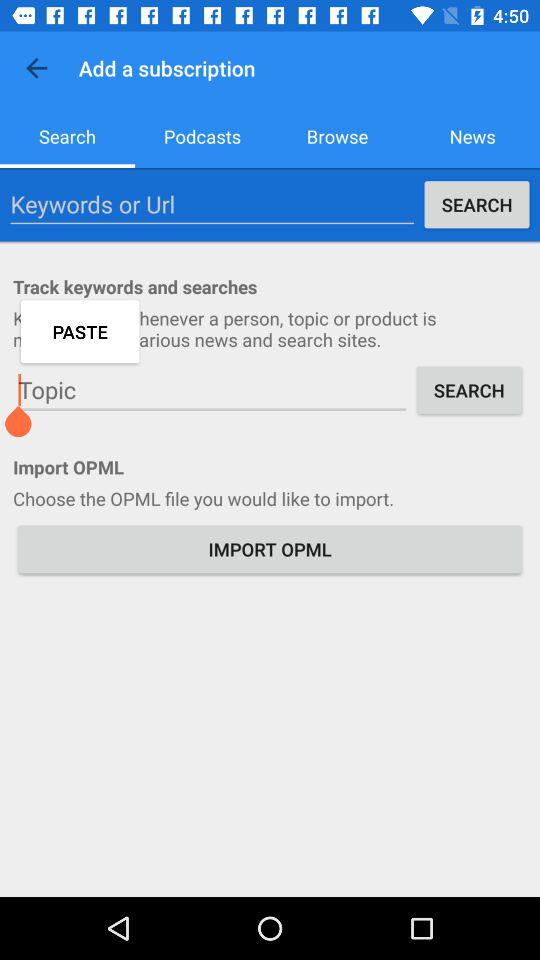Which tab is selected? The selected tab is "Search". 